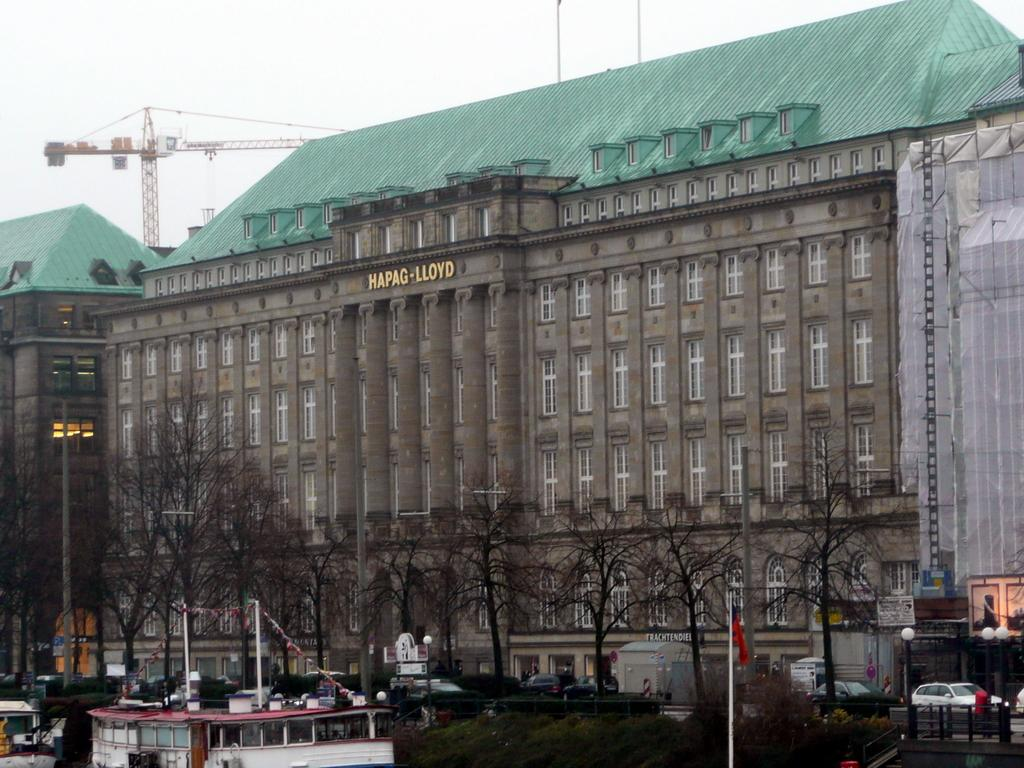What type of structures can be seen in the image? There are buildings in the image. What natural elements are present in the image? There are trees in the image. What mode of transportation can be seen in the image? There are boats in the image. What man-made objects are visible in the image? There are vehicles in the image. What vertical structures can be seen in the image? There are poles in the image. What type of lighting is present in the image? There are street lights in the image. What symbol can be seen in the image? There is a flag in the image. What tall structure is present in the image? There is a tower in the image. What part of the natural environment is visible in the image? The sky is visible in the image. Can you hear the sneeze of the seashore in the image? There is no sound or seashore present in the image, so it is not possible to hear a sneeze. What type of ship can be seen sailing near the tower in the image? There are no ships present in the image; it features boats, not ships. 